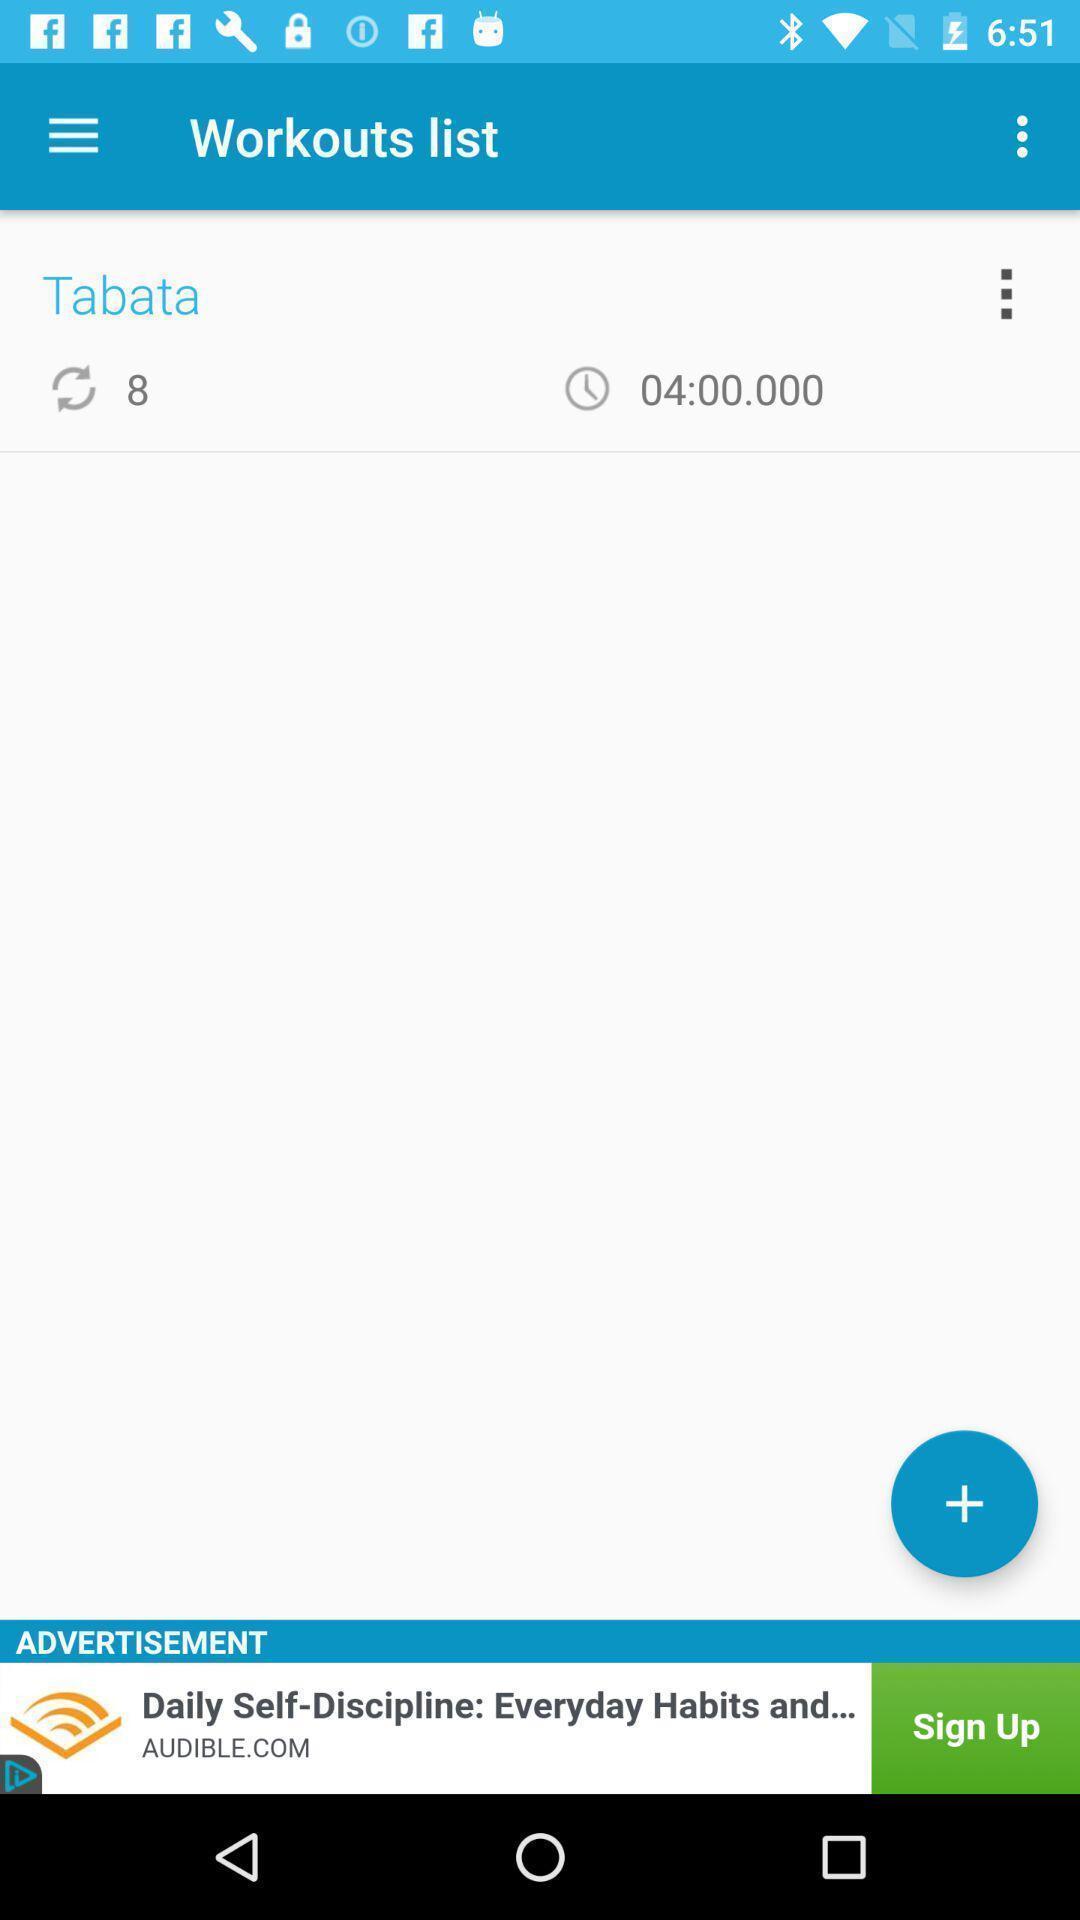Describe this image in words. Page showing list of exercises. 